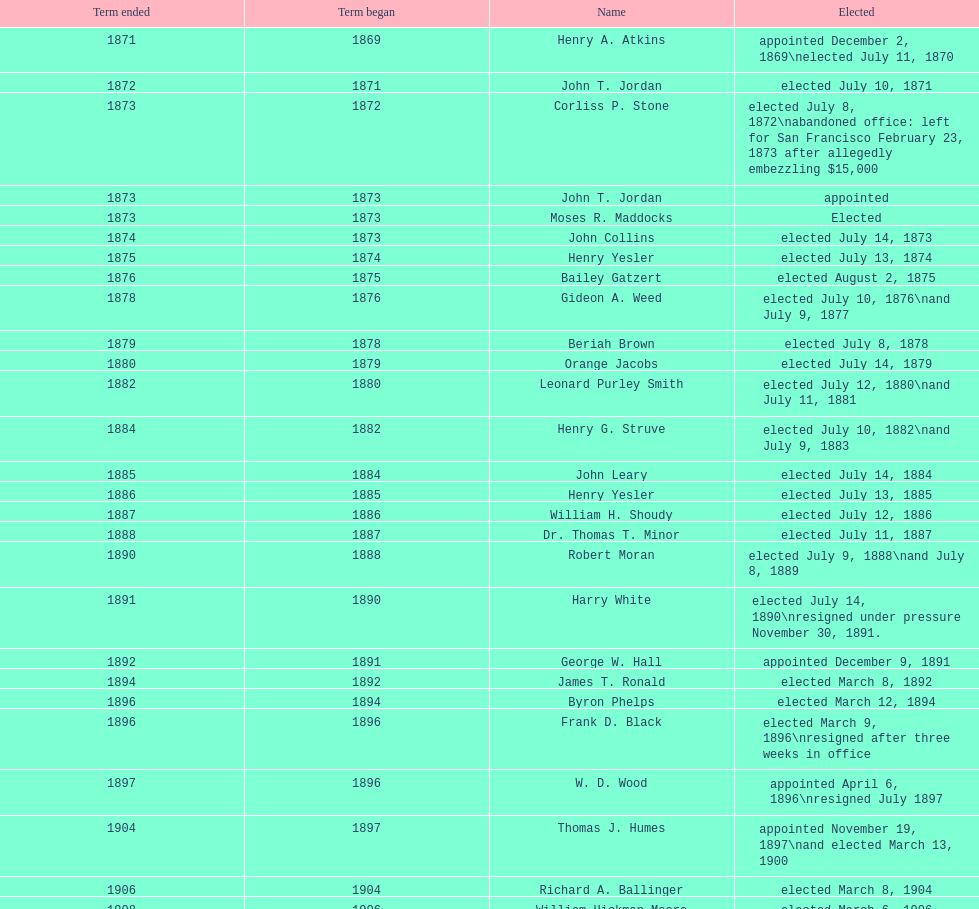Did charles royer hold office longer than paul schell? Yes. 